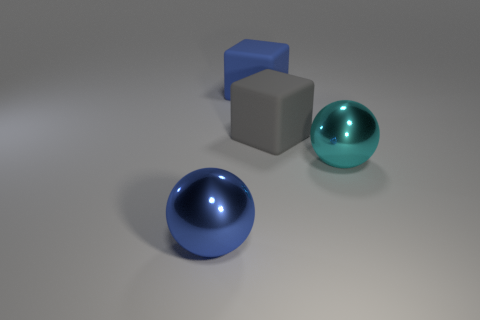Add 4 blocks. How many objects exist? 8 Add 1 large spheres. How many large spheres exist? 3 Subtract 0 brown blocks. How many objects are left? 4 Subtract all blue cubes. Subtract all big cyan metallic objects. How many objects are left? 2 Add 1 cyan shiny spheres. How many cyan shiny spheres are left? 2 